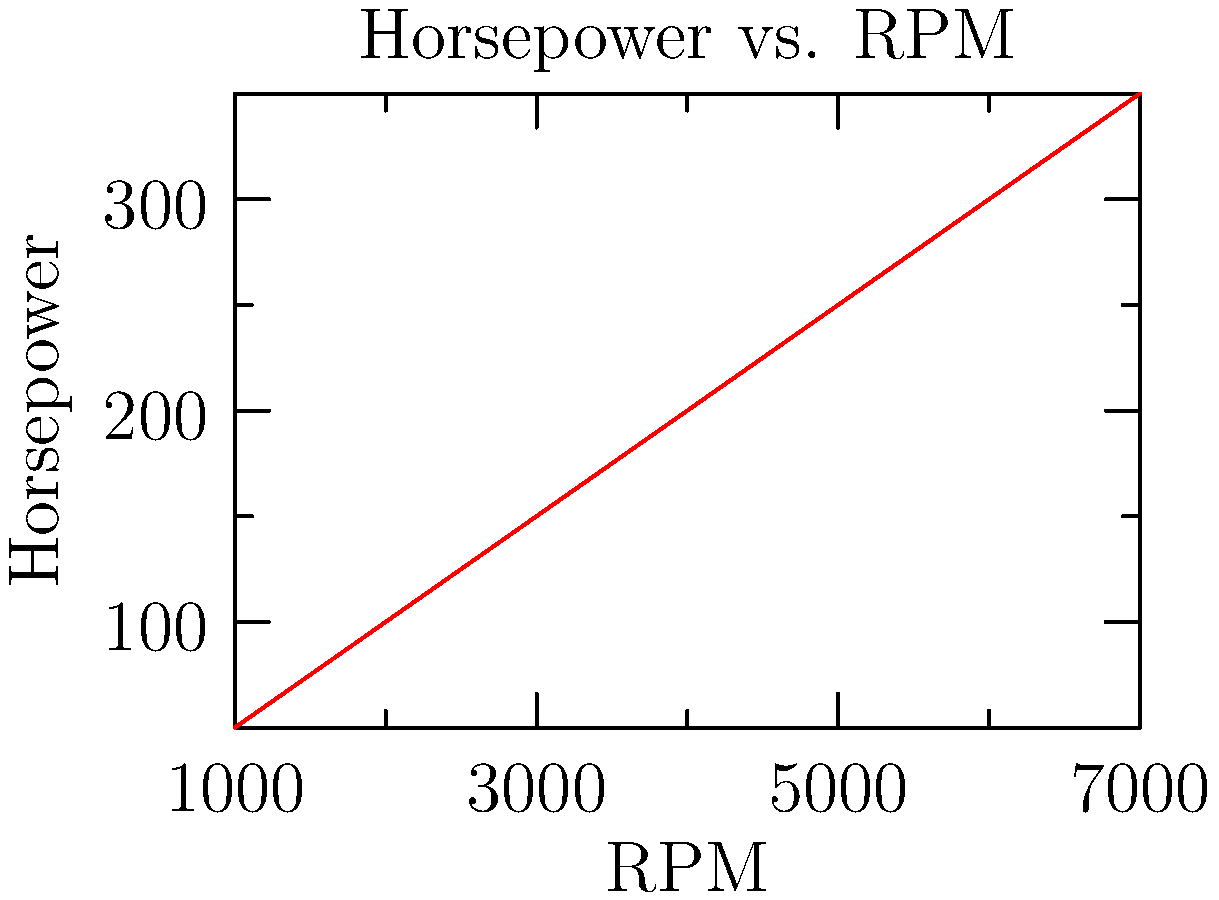Given the horsepower vs. RPM curve shown in the graph, calculate the peak torque of the engine in lb-ft. Assume the peak torque occurs at 4000 RPM. Use the formula: $T = (HP \times 5252) / RPM$, where $T$ is torque in lb-ft, $HP$ is horsepower, and $RPM$ is revolutions per minute. To solve this problem, we'll follow these steps:

1. Identify the horsepower at 4000 RPM from the graph:
   At 4000 RPM, the horsepower is approximately 200 HP.

2. Use the given formula to calculate torque:
   $T = (HP \times 5252) / RPM$

3. Plug in the values:
   $T = (200 \times 5252) / 4000$

4. Perform the calculation:
   $T = 1050400 / 4000 = 262.6$ lb-ft

Therefore, the peak torque at 4000 RPM is approximately 262.6 lb-ft.

This calculation demonstrates the relationship between horsepower, torque, and RPM, which is crucial in automotive engineering and engine design. It also highlights the importance of graphical data interpretation in analyzing engine performance characteristics.
Answer: 262.6 lb-ft 